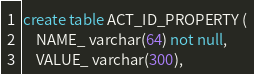Convert code to text. <code><loc_0><loc_0><loc_500><loc_500><_SQL_>create table ACT_ID_PROPERTY (
    NAME_ varchar(64) not null,
    VALUE_ varchar(300),</code> 